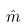Convert formula to latex. <formula><loc_0><loc_0><loc_500><loc_500>\hat { m }</formula> 